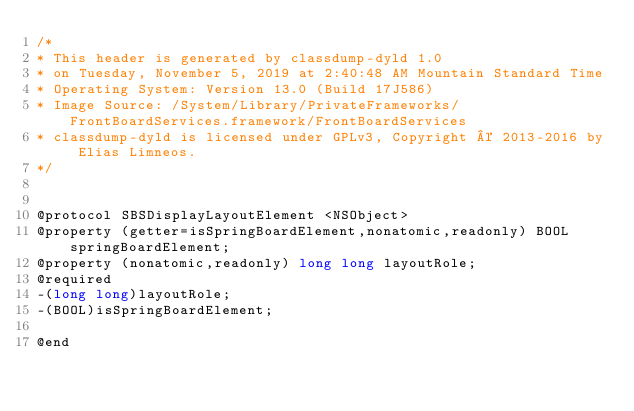Convert code to text. <code><loc_0><loc_0><loc_500><loc_500><_C_>/*
* This header is generated by classdump-dyld 1.0
* on Tuesday, November 5, 2019 at 2:40:48 AM Mountain Standard Time
* Operating System: Version 13.0 (Build 17J586)
* Image Source: /System/Library/PrivateFrameworks/FrontBoardServices.framework/FrontBoardServices
* classdump-dyld is licensed under GPLv3, Copyright © 2013-2016 by Elias Limneos.
*/


@protocol SBSDisplayLayoutElement <NSObject>
@property (getter=isSpringBoardElement,nonatomic,readonly) BOOL springBoardElement; 
@property (nonatomic,readonly) long long layoutRole; 
@required
-(long long)layoutRole;
-(BOOL)isSpringBoardElement;

@end

</code> 